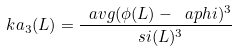Convert formula to latex. <formula><loc_0><loc_0><loc_500><loc_500>\ k a _ { 3 } ( L ) = \frac { \ a v g { ( \phi ( L ) - \ a p h i ) ^ { 3 } } } { \ s i ( L ) ^ { 3 } }</formula> 